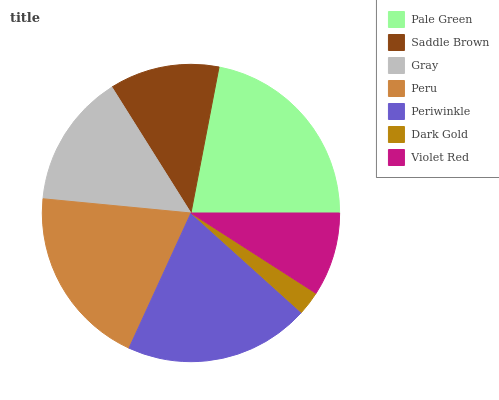Is Dark Gold the minimum?
Answer yes or no. Yes. Is Pale Green the maximum?
Answer yes or no. Yes. Is Saddle Brown the minimum?
Answer yes or no. No. Is Saddle Brown the maximum?
Answer yes or no. No. Is Pale Green greater than Saddle Brown?
Answer yes or no. Yes. Is Saddle Brown less than Pale Green?
Answer yes or no. Yes. Is Saddle Brown greater than Pale Green?
Answer yes or no. No. Is Pale Green less than Saddle Brown?
Answer yes or no. No. Is Gray the high median?
Answer yes or no. Yes. Is Gray the low median?
Answer yes or no. Yes. Is Pale Green the high median?
Answer yes or no. No. Is Periwinkle the low median?
Answer yes or no. No. 